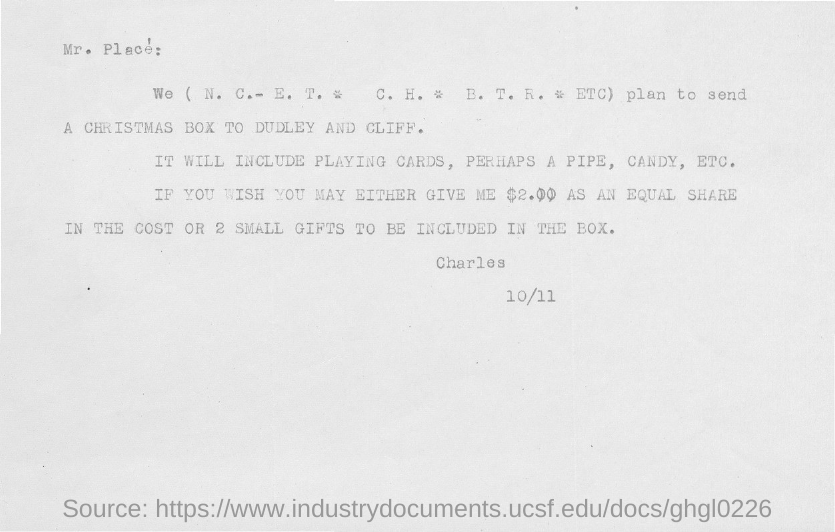List a handful of essential elements in this visual. The document is addressed to Mr. Place. The sender of this document is Charles. 